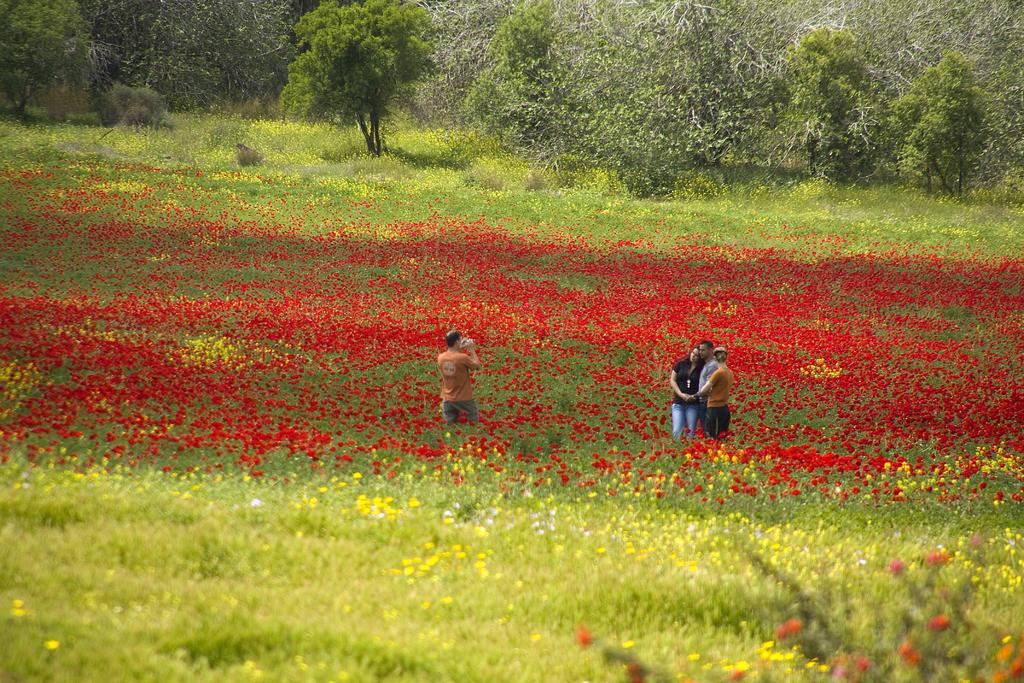What is the landscape like in the image? The land is covered with plants and flowers. Can you describe the people in the image? There are people standing in the image. What is the man holding in the image? A man is holding an object. What can be seen in the background of the image? There are trees in the background of the image. What type of plastic material can be seen in the image? There is no plastic material present in the image. How does the image make you feel? The image itself cannot make someone feel a certain way; feelings are subjective and depend on the viewer's personal experiences and emotions. 